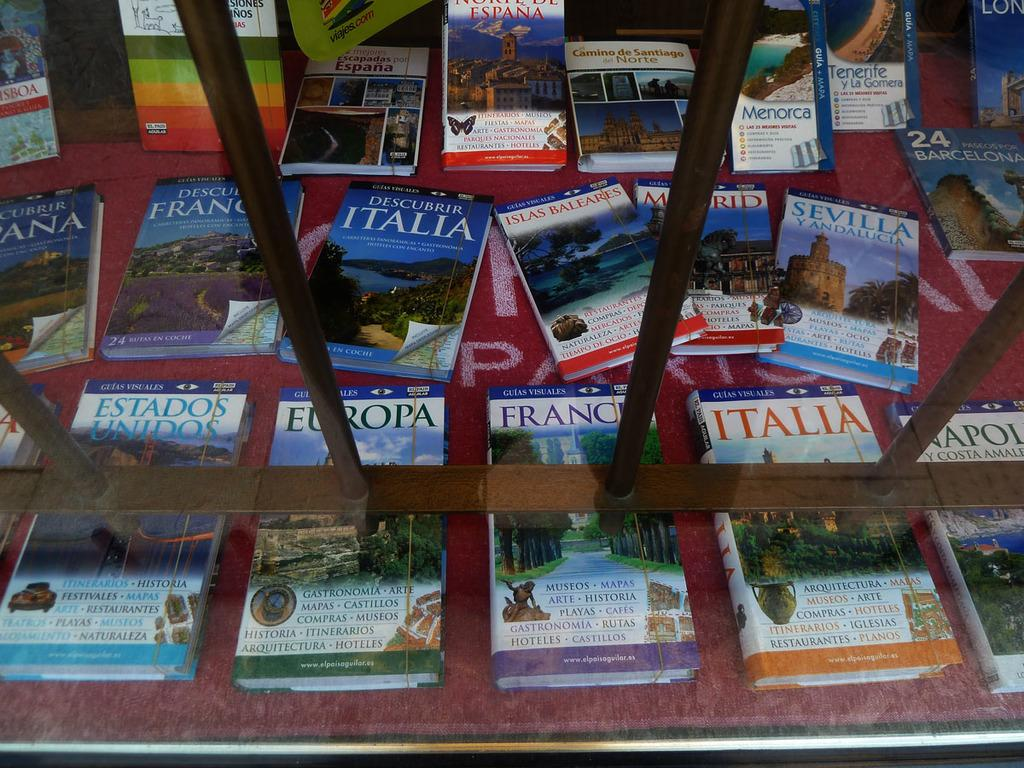Provide a one-sentence caption for the provided image. Books for various destinations including one titled Europa are laid out. 